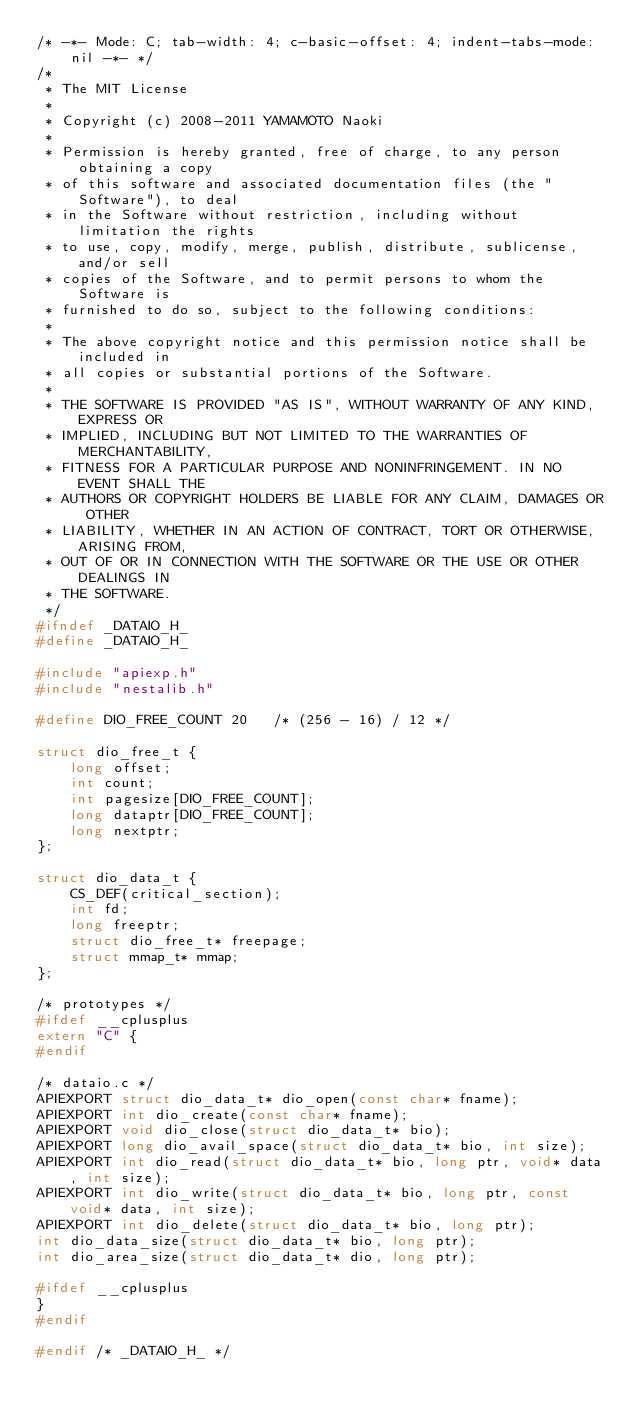<code> <loc_0><loc_0><loc_500><loc_500><_C_>/* -*- Mode: C; tab-width: 4; c-basic-offset: 4; indent-tabs-mode: nil -*- */
/*
 * The MIT License
 *
 * Copyright (c) 2008-2011 YAMAMOTO Naoki
 *
 * Permission is hereby granted, free of charge, to any person obtaining a copy
 * of this software and associated documentation files (the "Software"), to deal
 * in the Software without restriction, including without limitation the rights
 * to use, copy, modify, merge, publish, distribute, sublicense, and/or sell
 * copies of the Software, and to permit persons to whom the Software is
 * furnished to do so, subject to the following conditions:
 * 
 * The above copyright notice and this permission notice shall be included in
 * all copies or substantial portions of the Software.
 * 
 * THE SOFTWARE IS PROVIDED "AS IS", WITHOUT WARRANTY OF ANY KIND, EXPRESS OR
 * IMPLIED, INCLUDING BUT NOT LIMITED TO THE WARRANTIES OF MERCHANTABILITY,
 * FITNESS FOR A PARTICULAR PURPOSE AND NONINFRINGEMENT. IN NO EVENT SHALL THE
 * AUTHORS OR COPYRIGHT HOLDERS BE LIABLE FOR ANY CLAIM, DAMAGES OR OTHER
 * LIABILITY, WHETHER IN AN ACTION OF CONTRACT, TORT OR OTHERWISE, ARISING FROM,
 * OUT OF OR IN CONNECTION WITH THE SOFTWARE OR THE USE OR OTHER DEALINGS IN
 * THE SOFTWARE.
 */
#ifndef _DATAIO_H_
#define _DATAIO_H_

#include "apiexp.h"
#include "nestalib.h"

#define DIO_FREE_COUNT 20   /* (256 - 16) / 12 */

struct dio_free_t {
    long offset;
    int count;
    int pagesize[DIO_FREE_COUNT];
    long dataptr[DIO_FREE_COUNT];
    long nextptr;
};

struct dio_data_t {
    CS_DEF(critical_section);
    int fd;
    long freeptr;
    struct dio_free_t* freepage;
    struct mmap_t* mmap;
};

/* prototypes */
#ifdef __cplusplus
extern "C" {
#endif

/* dataio.c */
APIEXPORT struct dio_data_t* dio_open(const char* fname);
APIEXPORT int dio_create(const char* fname);
APIEXPORT void dio_close(struct dio_data_t* bio);
APIEXPORT long dio_avail_space(struct dio_data_t* bio, int size);
APIEXPORT int dio_read(struct dio_data_t* bio, long ptr, void* data, int size);
APIEXPORT int dio_write(struct dio_data_t* bio, long ptr, const void* data, int size);
APIEXPORT int dio_delete(struct dio_data_t* bio, long ptr);
int dio_data_size(struct dio_data_t* bio, long ptr);
int dio_area_size(struct dio_data_t* dio, long ptr);

#ifdef __cplusplus
}
#endif

#endif /* _DATAIO_H_ */
</code> 